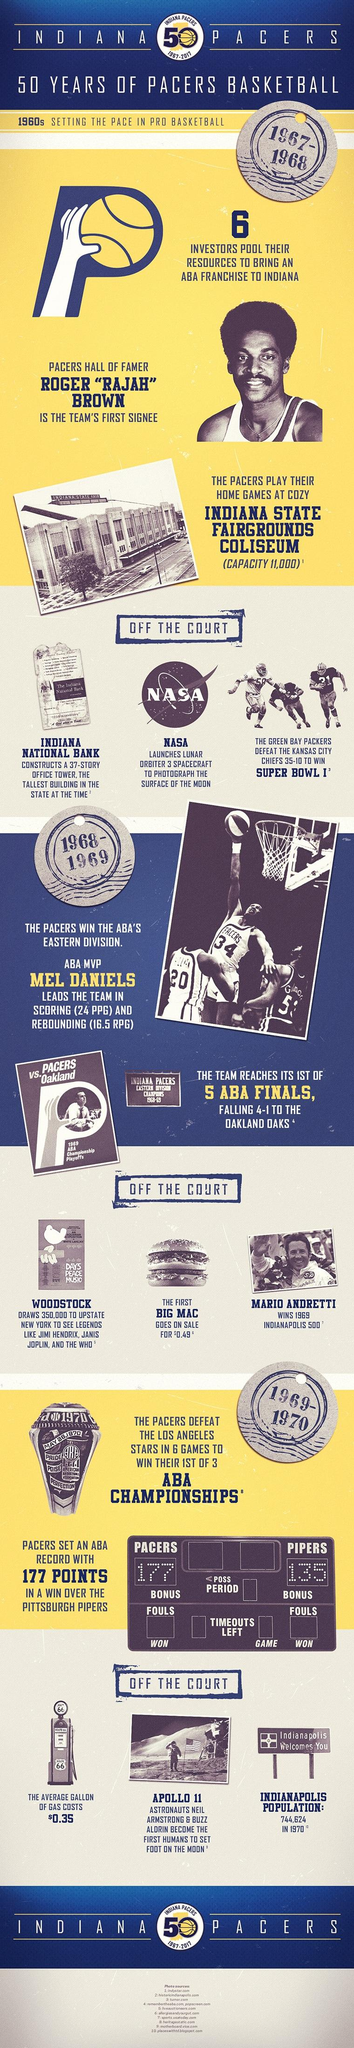Indicate a few pertinent items in this graphic. In 1967-68, NASA launched the lunar orbiter 3 spacecraft to photograph the surface of the moon. The first Big Mac cost 0.49 dollars. Neil Armstrong, using the vehicle named Apollo 11, became the first human to set foot on the moon on July 20, 1969. In the years 1969 and 1970, the cost of a gallon of gas was $0.35. The Pacers won their first of three ABA championships in the 1969-70 season. 